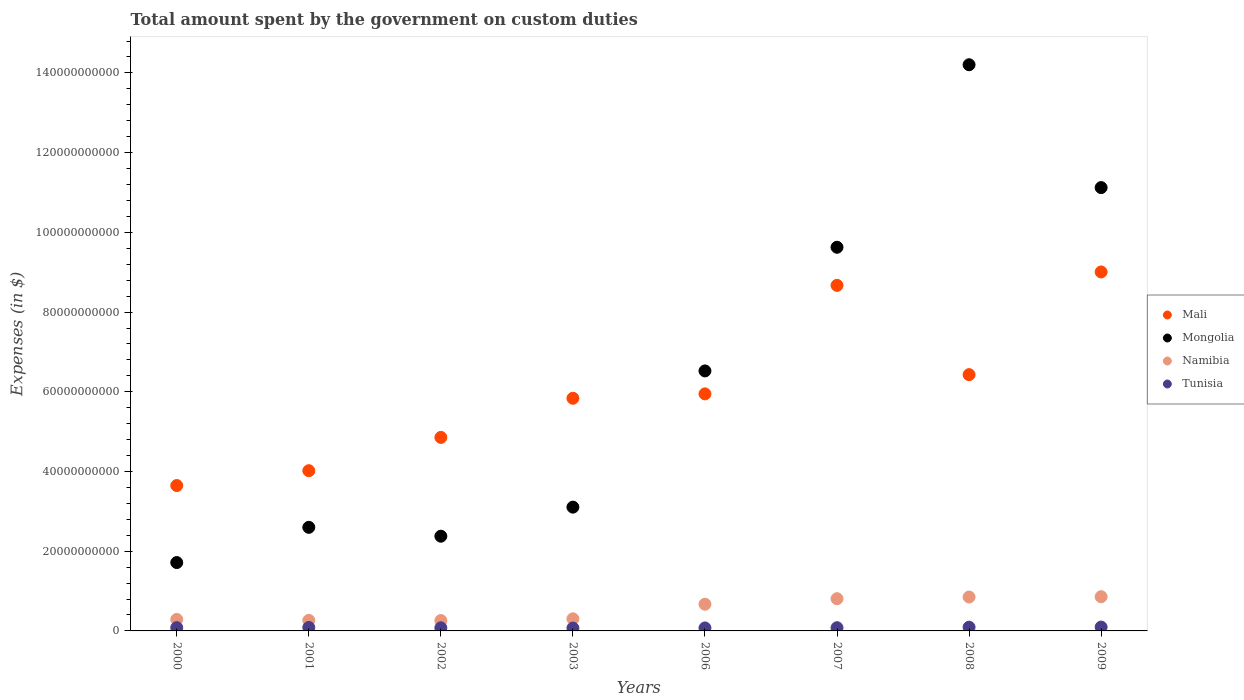What is the amount spent on custom duties by the government in Mali in 2002?
Your answer should be very brief. 4.86e+1. Across all years, what is the maximum amount spent on custom duties by the government in Namibia?
Provide a short and direct response. 8.59e+09. Across all years, what is the minimum amount spent on custom duties by the government in Tunisia?
Offer a terse response. 7.17e+08. In which year was the amount spent on custom duties by the government in Tunisia maximum?
Provide a short and direct response. 2009. What is the total amount spent on custom duties by the government in Tunisia in the graph?
Provide a short and direct response. 6.65e+09. What is the difference between the amount spent on custom duties by the government in Mongolia in 2008 and that in 2009?
Provide a succinct answer. 3.08e+1. What is the difference between the amount spent on custom duties by the government in Namibia in 2000 and the amount spent on custom duties by the government in Mali in 2009?
Your answer should be compact. -8.72e+1. What is the average amount spent on custom duties by the government in Namibia per year?
Offer a very short reply. 5.38e+09. In the year 2003, what is the difference between the amount spent on custom duties by the government in Namibia and amount spent on custom duties by the government in Mongolia?
Ensure brevity in your answer.  -2.80e+1. In how many years, is the amount spent on custom duties by the government in Tunisia greater than 24000000000 $?
Your answer should be compact. 0. What is the ratio of the amount spent on custom duties by the government in Namibia in 2008 to that in 2009?
Your response must be concise. 0.99. Is the amount spent on custom duties by the government in Tunisia in 2001 less than that in 2006?
Offer a very short reply. No. What is the difference between the highest and the second highest amount spent on custom duties by the government in Mali?
Provide a short and direct response. 3.36e+09. What is the difference between the highest and the lowest amount spent on custom duties by the government in Mongolia?
Offer a very short reply. 1.25e+11. Is the sum of the amount spent on custom duties by the government in Mongolia in 2002 and 2003 greater than the maximum amount spent on custom duties by the government in Namibia across all years?
Offer a very short reply. Yes. Is it the case that in every year, the sum of the amount spent on custom duties by the government in Mongolia and amount spent on custom duties by the government in Mali  is greater than the sum of amount spent on custom duties by the government in Tunisia and amount spent on custom duties by the government in Namibia?
Your answer should be very brief. No. Is it the case that in every year, the sum of the amount spent on custom duties by the government in Mali and amount spent on custom duties by the government in Namibia  is greater than the amount spent on custom duties by the government in Mongolia?
Give a very brief answer. No. Is the amount spent on custom duties by the government in Mongolia strictly greater than the amount spent on custom duties by the government in Tunisia over the years?
Make the answer very short. Yes. How many dotlines are there?
Make the answer very short. 4. How many years are there in the graph?
Provide a succinct answer. 8. Are the values on the major ticks of Y-axis written in scientific E-notation?
Offer a terse response. No. Does the graph contain any zero values?
Your response must be concise. No. Does the graph contain grids?
Make the answer very short. No. Where does the legend appear in the graph?
Provide a short and direct response. Center right. What is the title of the graph?
Offer a terse response. Total amount spent by the government on custom duties. Does "Austria" appear as one of the legend labels in the graph?
Your response must be concise. No. What is the label or title of the X-axis?
Give a very brief answer. Years. What is the label or title of the Y-axis?
Give a very brief answer. Expenses (in $). What is the Expenses (in $) in Mali in 2000?
Keep it short and to the point. 3.65e+1. What is the Expenses (in $) of Mongolia in 2000?
Give a very brief answer. 1.72e+1. What is the Expenses (in $) in Namibia in 2000?
Give a very brief answer. 2.88e+09. What is the Expenses (in $) of Tunisia in 2000?
Ensure brevity in your answer.  8.22e+08. What is the Expenses (in $) of Mali in 2001?
Offer a very short reply. 4.02e+1. What is the Expenses (in $) of Mongolia in 2001?
Your response must be concise. 2.60e+1. What is the Expenses (in $) of Namibia in 2001?
Your response must be concise. 2.64e+09. What is the Expenses (in $) in Tunisia in 2001?
Offer a terse response. 8.66e+08. What is the Expenses (in $) in Mali in 2002?
Your response must be concise. 4.86e+1. What is the Expenses (in $) of Mongolia in 2002?
Give a very brief answer. 2.38e+1. What is the Expenses (in $) of Namibia in 2002?
Ensure brevity in your answer.  2.60e+09. What is the Expenses (in $) of Tunisia in 2002?
Offer a very short reply. 7.81e+08. What is the Expenses (in $) of Mali in 2003?
Give a very brief answer. 5.84e+1. What is the Expenses (in $) in Mongolia in 2003?
Give a very brief answer. 3.11e+1. What is the Expenses (in $) of Namibia in 2003?
Keep it short and to the point. 3.04e+09. What is the Expenses (in $) of Tunisia in 2003?
Keep it short and to the point. 7.17e+08. What is the Expenses (in $) in Mali in 2006?
Provide a succinct answer. 5.95e+1. What is the Expenses (in $) of Mongolia in 2006?
Make the answer very short. 6.52e+1. What is the Expenses (in $) in Namibia in 2006?
Offer a terse response. 6.70e+09. What is the Expenses (in $) of Tunisia in 2006?
Make the answer very short. 7.47e+08. What is the Expenses (in $) of Mali in 2007?
Offer a terse response. 8.67e+1. What is the Expenses (in $) of Mongolia in 2007?
Keep it short and to the point. 9.63e+1. What is the Expenses (in $) in Namibia in 2007?
Ensure brevity in your answer.  8.09e+09. What is the Expenses (in $) of Tunisia in 2007?
Give a very brief answer. 8.04e+08. What is the Expenses (in $) in Mali in 2008?
Keep it short and to the point. 6.43e+1. What is the Expenses (in $) of Mongolia in 2008?
Provide a succinct answer. 1.42e+11. What is the Expenses (in $) in Namibia in 2008?
Your response must be concise. 8.50e+09. What is the Expenses (in $) in Tunisia in 2008?
Keep it short and to the point. 9.40e+08. What is the Expenses (in $) of Mali in 2009?
Provide a succinct answer. 9.01e+1. What is the Expenses (in $) of Mongolia in 2009?
Give a very brief answer. 1.11e+11. What is the Expenses (in $) of Namibia in 2009?
Offer a terse response. 8.59e+09. What is the Expenses (in $) of Tunisia in 2009?
Keep it short and to the point. 9.72e+08. Across all years, what is the maximum Expenses (in $) in Mali?
Provide a succinct answer. 9.01e+1. Across all years, what is the maximum Expenses (in $) in Mongolia?
Your response must be concise. 1.42e+11. Across all years, what is the maximum Expenses (in $) of Namibia?
Offer a terse response. 8.59e+09. Across all years, what is the maximum Expenses (in $) of Tunisia?
Make the answer very short. 9.72e+08. Across all years, what is the minimum Expenses (in $) of Mali?
Your response must be concise. 3.65e+1. Across all years, what is the minimum Expenses (in $) of Mongolia?
Provide a short and direct response. 1.72e+1. Across all years, what is the minimum Expenses (in $) in Namibia?
Your answer should be compact. 2.60e+09. Across all years, what is the minimum Expenses (in $) in Tunisia?
Make the answer very short. 7.17e+08. What is the total Expenses (in $) in Mali in the graph?
Provide a succinct answer. 4.84e+11. What is the total Expenses (in $) in Mongolia in the graph?
Your response must be concise. 5.13e+11. What is the total Expenses (in $) in Namibia in the graph?
Your answer should be very brief. 4.30e+1. What is the total Expenses (in $) of Tunisia in the graph?
Give a very brief answer. 6.65e+09. What is the difference between the Expenses (in $) in Mali in 2000 and that in 2001?
Give a very brief answer. -3.72e+09. What is the difference between the Expenses (in $) in Mongolia in 2000 and that in 2001?
Your response must be concise. -8.84e+09. What is the difference between the Expenses (in $) in Namibia in 2000 and that in 2001?
Ensure brevity in your answer.  2.35e+08. What is the difference between the Expenses (in $) in Tunisia in 2000 and that in 2001?
Provide a succinct answer. -4.38e+07. What is the difference between the Expenses (in $) of Mali in 2000 and that in 2002?
Provide a succinct answer. -1.21e+1. What is the difference between the Expenses (in $) of Mongolia in 2000 and that in 2002?
Offer a very short reply. -6.61e+09. What is the difference between the Expenses (in $) in Namibia in 2000 and that in 2002?
Your answer should be very brief. 2.79e+08. What is the difference between the Expenses (in $) of Tunisia in 2000 and that in 2002?
Provide a succinct answer. 4.11e+07. What is the difference between the Expenses (in $) in Mali in 2000 and that in 2003?
Provide a short and direct response. -2.19e+1. What is the difference between the Expenses (in $) of Mongolia in 2000 and that in 2003?
Provide a short and direct response. -1.39e+1. What is the difference between the Expenses (in $) of Namibia in 2000 and that in 2003?
Offer a very short reply. -1.59e+08. What is the difference between the Expenses (in $) in Tunisia in 2000 and that in 2003?
Keep it short and to the point. 1.05e+08. What is the difference between the Expenses (in $) in Mali in 2000 and that in 2006?
Provide a succinct answer. -2.30e+1. What is the difference between the Expenses (in $) in Mongolia in 2000 and that in 2006?
Give a very brief answer. -4.81e+1. What is the difference between the Expenses (in $) of Namibia in 2000 and that in 2006?
Your answer should be very brief. -3.82e+09. What is the difference between the Expenses (in $) in Tunisia in 2000 and that in 2006?
Provide a short and direct response. 7.54e+07. What is the difference between the Expenses (in $) in Mali in 2000 and that in 2007?
Make the answer very short. -5.02e+1. What is the difference between the Expenses (in $) of Mongolia in 2000 and that in 2007?
Offer a very short reply. -7.91e+1. What is the difference between the Expenses (in $) of Namibia in 2000 and that in 2007?
Offer a terse response. -5.21e+09. What is the difference between the Expenses (in $) of Tunisia in 2000 and that in 2007?
Provide a succinct answer. 1.88e+07. What is the difference between the Expenses (in $) in Mali in 2000 and that in 2008?
Ensure brevity in your answer.  -2.78e+1. What is the difference between the Expenses (in $) in Mongolia in 2000 and that in 2008?
Make the answer very short. -1.25e+11. What is the difference between the Expenses (in $) of Namibia in 2000 and that in 2008?
Your answer should be very brief. -5.62e+09. What is the difference between the Expenses (in $) in Tunisia in 2000 and that in 2008?
Your answer should be very brief. -1.18e+08. What is the difference between the Expenses (in $) in Mali in 2000 and that in 2009?
Your response must be concise. -5.36e+1. What is the difference between the Expenses (in $) in Mongolia in 2000 and that in 2009?
Your answer should be very brief. -9.41e+1. What is the difference between the Expenses (in $) in Namibia in 2000 and that in 2009?
Your answer should be compact. -5.71e+09. What is the difference between the Expenses (in $) of Tunisia in 2000 and that in 2009?
Provide a succinct answer. -1.50e+08. What is the difference between the Expenses (in $) of Mali in 2001 and that in 2002?
Ensure brevity in your answer.  -8.35e+09. What is the difference between the Expenses (in $) in Mongolia in 2001 and that in 2002?
Make the answer very short. 2.22e+09. What is the difference between the Expenses (in $) in Namibia in 2001 and that in 2002?
Your answer should be very brief. 4.42e+07. What is the difference between the Expenses (in $) of Tunisia in 2001 and that in 2002?
Provide a succinct answer. 8.49e+07. What is the difference between the Expenses (in $) of Mali in 2001 and that in 2003?
Ensure brevity in your answer.  -1.82e+1. What is the difference between the Expenses (in $) of Mongolia in 2001 and that in 2003?
Offer a very short reply. -5.07e+09. What is the difference between the Expenses (in $) in Namibia in 2001 and that in 2003?
Make the answer very short. -3.94e+08. What is the difference between the Expenses (in $) of Tunisia in 2001 and that in 2003?
Keep it short and to the point. 1.49e+08. What is the difference between the Expenses (in $) in Mali in 2001 and that in 2006?
Keep it short and to the point. -1.93e+1. What is the difference between the Expenses (in $) in Mongolia in 2001 and that in 2006?
Provide a short and direct response. -3.92e+1. What is the difference between the Expenses (in $) in Namibia in 2001 and that in 2006?
Make the answer very short. -4.06e+09. What is the difference between the Expenses (in $) in Tunisia in 2001 and that in 2006?
Offer a very short reply. 1.19e+08. What is the difference between the Expenses (in $) of Mali in 2001 and that in 2007?
Your response must be concise. -4.65e+1. What is the difference between the Expenses (in $) in Mongolia in 2001 and that in 2007?
Give a very brief answer. -7.03e+1. What is the difference between the Expenses (in $) in Namibia in 2001 and that in 2007?
Your answer should be compact. -5.44e+09. What is the difference between the Expenses (in $) of Tunisia in 2001 and that in 2007?
Make the answer very short. 6.26e+07. What is the difference between the Expenses (in $) in Mali in 2001 and that in 2008?
Your answer should be compact. -2.41e+1. What is the difference between the Expenses (in $) of Mongolia in 2001 and that in 2008?
Offer a terse response. -1.16e+11. What is the difference between the Expenses (in $) in Namibia in 2001 and that in 2008?
Give a very brief answer. -5.86e+09. What is the difference between the Expenses (in $) in Tunisia in 2001 and that in 2008?
Provide a short and direct response. -7.37e+07. What is the difference between the Expenses (in $) in Mali in 2001 and that in 2009?
Keep it short and to the point. -4.99e+1. What is the difference between the Expenses (in $) in Mongolia in 2001 and that in 2009?
Offer a terse response. -8.52e+1. What is the difference between the Expenses (in $) in Namibia in 2001 and that in 2009?
Offer a very short reply. -5.94e+09. What is the difference between the Expenses (in $) in Tunisia in 2001 and that in 2009?
Give a very brief answer. -1.06e+08. What is the difference between the Expenses (in $) of Mali in 2002 and that in 2003?
Ensure brevity in your answer.  -9.82e+09. What is the difference between the Expenses (in $) in Mongolia in 2002 and that in 2003?
Make the answer very short. -7.29e+09. What is the difference between the Expenses (in $) in Namibia in 2002 and that in 2003?
Offer a very short reply. -4.38e+08. What is the difference between the Expenses (in $) of Tunisia in 2002 and that in 2003?
Give a very brief answer. 6.41e+07. What is the difference between the Expenses (in $) in Mali in 2002 and that in 2006?
Give a very brief answer. -1.09e+1. What is the difference between the Expenses (in $) in Mongolia in 2002 and that in 2006?
Your answer should be very brief. -4.15e+1. What is the difference between the Expenses (in $) of Namibia in 2002 and that in 2006?
Give a very brief answer. -4.10e+09. What is the difference between the Expenses (in $) of Tunisia in 2002 and that in 2006?
Make the answer very short. 3.43e+07. What is the difference between the Expenses (in $) in Mali in 2002 and that in 2007?
Your answer should be compact. -3.81e+1. What is the difference between the Expenses (in $) of Mongolia in 2002 and that in 2007?
Provide a short and direct response. -7.25e+1. What is the difference between the Expenses (in $) in Namibia in 2002 and that in 2007?
Provide a short and direct response. -5.49e+09. What is the difference between the Expenses (in $) of Tunisia in 2002 and that in 2007?
Ensure brevity in your answer.  -2.23e+07. What is the difference between the Expenses (in $) in Mali in 2002 and that in 2008?
Your answer should be very brief. -1.57e+1. What is the difference between the Expenses (in $) in Mongolia in 2002 and that in 2008?
Provide a succinct answer. -1.18e+11. What is the difference between the Expenses (in $) in Namibia in 2002 and that in 2008?
Make the answer very short. -5.90e+09. What is the difference between the Expenses (in $) of Tunisia in 2002 and that in 2008?
Make the answer very short. -1.59e+08. What is the difference between the Expenses (in $) in Mali in 2002 and that in 2009?
Give a very brief answer. -4.15e+1. What is the difference between the Expenses (in $) in Mongolia in 2002 and that in 2009?
Your answer should be compact. -8.75e+1. What is the difference between the Expenses (in $) of Namibia in 2002 and that in 2009?
Ensure brevity in your answer.  -5.99e+09. What is the difference between the Expenses (in $) of Tunisia in 2002 and that in 2009?
Provide a short and direct response. -1.91e+08. What is the difference between the Expenses (in $) of Mali in 2003 and that in 2006?
Offer a very short reply. -1.10e+09. What is the difference between the Expenses (in $) of Mongolia in 2003 and that in 2006?
Provide a succinct answer. -3.42e+1. What is the difference between the Expenses (in $) in Namibia in 2003 and that in 2006?
Provide a short and direct response. -3.66e+09. What is the difference between the Expenses (in $) of Tunisia in 2003 and that in 2006?
Provide a succinct answer. -2.98e+07. What is the difference between the Expenses (in $) in Mali in 2003 and that in 2007?
Keep it short and to the point. -2.83e+1. What is the difference between the Expenses (in $) of Mongolia in 2003 and that in 2007?
Ensure brevity in your answer.  -6.52e+1. What is the difference between the Expenses (in $) in Namibia in 2003 and that in 2007?
Provide a succinct answer. -5.05e+09. What is the difference between the Expenses (in $) of Tunisia in 2003 and that in 2007?
Keep it short and to the point. -8.64e+07. What is the difference between the Expenses (in $) in Mali in 2003 and that in 2008?
Provide a succinct answer. -5.92e+09. What is the difference between the Expenses (in $) of Mongolia in 2003 and that in 2008?
Your response must be concise. -1.11e+11. What is the difference between the Expenses (in $) of Namibia in 2003 and that in 2008?
Give a very brief answer. -5.47e+09. What is the difference between the Expenses (in $) of Tunisia in 2003 and that in 2008?
Ensure brevity in your answer.  -2.23e+08. What is the difference between the Expenses (in $) of Mali in 2003 and that in 2009?
Ensure brevity in your answer.  -3.17e+1. What is the difference between the Expenses (in $) of Mongolia in 2003 and that in 2009?
Provide a succinct answer. -8.02e+1. What is the difference between the Expenses (in $) in Namibia in 2003 and that in 2009?
Ensure brevity in your answer.  -5.55e+09. What is the difference between the Expenses (in $) of Tunisia in 2003 and that in 2009?
Provide a short and direct response. -2.55e+08. What is the difference between the Expenses (in $) in Mali in 2006 and that in 2007?
Provide a succinct answer. -2.72e+1. What is the difference between the Expenses (in $) of Mongolia in 2006 and that in 2007?
Your response must be concise. -3.10e+1. What is the difference between the Expenses (in $) in Namibia in 2006 and that in 2007?
Your answer should be very brief. -1.39e+09. What is the difference between the Expenses (in $) in Tunisia in 2006 and that in 2007?
Provide a short and direct response. -5.66e+07. What is the difference between the Expenses (in $) in Mali in 2006 and that in 2008?
Your answer should be very brief. -4.83e+09. What is the difference between the Expenses (in $) of Mongolia in 2006 and that in 2008?
Offer a terse response. -7.68e+1. What is the difference between the Expenses (in $) in Namibia in 2006 and that in 2008?
Your response must be concise. -1.80e+09. What is the difference between the Expenses (in $) in Tunisia in 2006 and that in 2008?
Keep it short and to the point. -1.93e+08. What is the difference between the Expenses (in $) in Mali in 2006 and that in 2009?
Ensure brevity in your answer.  -3.06e+1. What is the difference between the Expenses (in $) of Mongolia in 2006 and that in 2009?
Provide a succinct answer. -4.60e+1. What is the difference between the Expenses (in $) in Namibia in 2006 and that in 2009?
Your response must be concise. -1.89e+09. What is the difference between the Expenses (in $) in Tunisia in 2006 and that in 2009?
Offer a very short reply. -2.25e+08. What is the difference between the Expenses (in $) of Mali in 2007 and that in 2008?
Your answer should be very brief. 2.24e+1. What is the difference between the Expenses (in $) in Mongolia in 2007 and that in 2008?
Your answer should be very brief. -4.58e+1. What is the difference between the Expenses (in $) of Namibia in 2007 and that in 2008?
Provide a short and direct response. -4.17e+08. What is the difference between the Expenses (in $) in Tunisia in 2007 and that in 2008?
Your answer should be compact. -1.36e+08. What is the difference between the Expenses (in $) of Mali in 2007 and that in 2009?
Provide a succinct answer. -3.36e+09. What is the difference between the Expenses (in $) in Mongolia in 2007 and that in 2009?
Offer a terse response. -1.50e+1. What is the difference between the Expenses (in $) of Namibia in 2007 and that in 2009?
Your response must be concise. -5.00e+08. What is the difference between the Expenses (in $) of Tunisia in 2007 and that in 2009?
Make the answer very short. -1.68e+08. What is the difference between the Expenses (in $) in Mali in 2008 and that in 2009?
Ensure brevity in your answer.  -2.58e+1. What is the difference between the Expenses (in $) in Mongolia in 2008 and that in 2009?
Provide a short and direct response. 3.08e+1. What is the difference between the Expenses (in $) of Namibia in 2008 and that in 2009?
Your response must be concise. -8.30e+07. What is the difference between the Expenses (in $) in Tunisia in 2008 and that in 2009?
Your response must be concise. -3.20e+07. What is the difference between the Expenses (in $) in Mali in 2000 and the Expenses (in $) in Mongolia in 2001?
Your answer should be compact. 1.05e+1. What is the difference between the Expenses (in $) in Mali in 2000 and the Expenses (in $) in Namibia in 2001?
Offer a terse response. 3.38e+1. What is the difference between the Expenses (in $) in Mali in 2000 and the Expenses (in $) in Tunisia in 2001?
Your answer should be compact. 3.56e+1. What is the difference between the Expenses (in $) in Mongolia in 2000 and the Expenses (in $) in Namibia in 2001?
Keep it short and to the point. 1.45e+1. What is the difference between the Expenses (in $) of Mongolia in 2000 and the Expenses (in $) of Tunisia in 2001?
Keep it short and to the point. 1.63e+1. What is the difference between the Expenses (in $) in Namibia in 2000 and the Expenses (in $) in Tunisia in 2001?
Offer a very short reply. 2.01e+09. What is the difference between the Expenses (in $) of Mali in 2000 and the Expenses (in $) of Mongolia in 2002?
Offer a terse response. 1.27e+1. What is the difference between the Expenses (in $) in Mali in 2000 and the Expenses (in $) in Namibia in 2002?
Offer a very short reply. 3.39e+1. What is the difference between the Expenses (in $) in Mali in 2000 and the Expenses (in $) in Tunisia in 2002?
Provide a short and direct response. 3.57e+1. What is the difference between the Expenses (in $) of Mongolia in 2000 and the Expenses (in $) of Namibia in 2002?
Provide a succinct answer. 1.46e+1. What is the difference between the Expenses (in $) of Mongolia in 2000 and the Expenses (in $) of Tunisia in 2002?
Offer a very short reply. 1.64e+1. What is the difference between the Expenses (in $) of Namibia in 2000 and the Expenses (in $) of Tunisia in 2002?
Keep it short and to the point. 2.10e+09. What is the difference between the Expenses (in $) of Mali in 2000 and the Expenses (in $) of Mongolia in 2003?
Ensure brevity in your answer.  5.42e+09. What is the difference between the Expenses (in $) in Mali in 2000 and the Expenses (in $) in Namibia in 2003?
Provide a succinct answer. 3.34e+1. What is the difference between the Expenses (in $) of Mali in 2000 and the Expenses (in $) of Tunisia in 2003?
Provide a short and direct response. 3.58e+1. What is the difference between the Expenses (in $) of Mongolia in 2000 and the Expenses (in $) of Namibia in 2003?
Your answer should be very brief. 1.41e+1. What is the difference between the Expenses (in $) in Mongolia in 2000 and the Expenses (in $) in Tunisia in 2003?
Ensure brevity in your answer.  1.64e+1. What is the difference between the Expenses (in $) of Namibia in 2000 and the Expenses (in $) of Tunisia in 2003?
Your answer should be very brief. 2.16e+09. What is the difference between the Expenses (in $) in Mali in 2000 and the Expenses (in $) in Mongolia in 2006?
Your answer should be very brief. -2.88e+1. What is the difference between the Expenses (in $) of Mali in 2000 and the Expenses (in $) of Namibia in 2006?
Ensure brevity in your answer.  2.98e+1. What is the difference between the Expenses (in $) of Mali in 2000 and the Expenses (in $) of Tunisia in 2006?
Your answer should be compact. 3.57e+1. What is the difference between the Expenses (in $) of Mongolia in 2000 and the Expenses (in $) of Namibia in 2006?
Keep it short and to the point. 1.05e+1. What is the difference between the Expenses (in $) in Mongolia in 2000 and the Expenses (in $) in Tunisia in 2006?
Your response must be concise. 1.64e+1. What is the difference between the Expenses (in $) of Namibia in 2000 and the Expenses (in $) of Tunisia in 2006?
Make the answer very short. 2.13e+09. What is the difference between the Expenses (in $) of Mali in 2000 and the Expenses (in $) of Mongolia in 2007?
Your response must be concise. -5.98e+1. What is the difference between the Expenses (in $) in Mali in 2000 and the Expenses (in $) in Namibia in 2007?
Your response must be concise. 2.84e+1. What is the difference between the Expenses (in $) of Mali in 2000 and the Expenses (in $) of Tunisia in 2007?
Your answer should be very brief. 3.57e+1. What is the difference between the Expenses (in $) of Mongolia in 2000 and the Expenses (in $) of Namibia in 2007?
Provide a short and direct response. 9.07e+09. What is the difference between the Expenses (in $) of Mongolia in 2000 and the Expenses (in $) of Tunisia in 2007?
Ensure brevity in your answer.  1.63e+1. What is the difference between the Expenses (in $) of Namibia in 2000 and the Expenses (in $) of Tunisia in 2007?
Make the answer very short. 2.07e+09. What is the difference between the Expenses (in $) in Mali in 2000 and the Expenses (in $) in Mongolia in 2008?
Give a very brief answer. -1.06e+11. What is the difference between the Expenses (in $) of Mali in 2000 and the Expenses (in $) of Namibia in 2008?
Ensure brevity in your answer.  2.80e+1. What is the difference between the Expenses (in $) of Mali in 2000 and the Expenses (in $) of Tunisia in 2008?
Offer a terse response. 3.55e+1. What is the difference between the Expenses (in $) in Mongolia in 2000 and the Expenses (in $) in Namibia in 2008?
Ensure brevity in your answer.  8.65e+09. What is the difference between the Expenses (in $) of Mongolia in 2000 and the Expenses (in $) of Tunisia in 2008?
Provide a succinct answer. 1.62e+1. What is the difference between the Expenses (in $) of Namibia in 2000 and the Expenses (in $) of Tunisia in 2008?
Your response must be concise. 1.94e+09. What is the difference between the Expenses (in $) of Mali in 2000 and the Expenses (in $) of Mongolia in 2009?
Provide a short and direct response. -7.48e+1. What is the difference between the Expenses (in $) of Mali in 2000 and the Expenses (in $) of Namibia in 2009?
Offer a terse response. 2.79e+1. What is the difference between the Expenses (in $) of Mali in 2000 and the Expenses (in $) of Tunisia in 2009?
Give a very brief answer. 3.55e+1. What is the difference between the Expenses (in $) of Mongolia in 2000 and the Expenses (in $) of Namibia in 2009?
Make the answer very short. 8.57e+09. What is the difference between the Expenses (in $) of Mongolia in 2000 and the Expenses (in $) of Tunisia in 2009?
Provide a succinct answer. 1.62e+1. What is the difference between the Expenses (in $) of Namibia in 2000 and the Expenses (in $) of Tunisia in 2009?
Your answer should be compact. 1.91e+09. What is the difference between the Expenses (in $) in Mali in 2001 and the Expenses (in $) in Mongolia in 2002?
Your answer should be compact. 1.64e+1. What is the difference between the Expenses (in $) in Mali in 2001 and the Expenses (in $) in Namibia in 2002?
Provide a short and direct response. 3.76e+1. What is the difference between the Expenses (in $) of Mali in 2001 and the Expenses (in $) of Tunisia in 2002?
Your answer should be very brief. 3.94e+1. What is the difference between the Expenses (in $) of Mongolia in 2001 and the Expenses (in $) of Namibia in 2002?
Give a very brief answer. 2.34e+1. What is the difference between the Expenses (in $) in Mongolia in 2001 and the Expenses (in $) in Tunisia in 2002?
Offer a terse response. 2.52e+1. What is the difference between the Expenses (in $) in Namibia in 2001 and the Expenses (in $) in Tunisia in 2002?
Keep it short and to the point. 1.86e+09. What is the difference between the Expenses (in $) in Mali in 2001 and the Expenses (in $) in Mongolia in 2003?
Make the answer very short. 9.14e+09. What is the difference between the Expenses (in $) in Mali in 2001 and the Expenses (in $) in Namibia in 2003?
Make the answer very short. 3.72e+1. What is the difference between the Expenses (in $) in Mali in 2001 and the Expenses (in $) in Tunisia in 2003?
Make the answer very short. 3.95e+1. What is the difference between the Expenses (in $) of Mongolia in 2001 and the Expenses (in $) of Namibia in 2003?
Offer a terse response. 2.30e+1. What is the difference between the Expenses (in $) in Mongolia in 2001 and the Expenses (in $) in Tunisia in 2003?
Give a very brief answer. 2.53e+1. What is the difference between the Expenses (in $) of Namibia in 2001 and the Expenses (in $) of Tunisia in 2003?
Your response must be concise. 1.93e+09. What is the difference between the Expenses (in $) in Mali in 2001 and the Expenses (in $) in Mongolia in 2006?
Provide a short and direct response. -2.50e+1. What is the difference between the Expenses (in $) of Mali in 2001 and the Expenses (in $) of Namibia in 2006?
Provide a short and direct response. 3.35e+1. What is the difference between the Expenses (in $) in Mali in 2001 and the Expenses (in $) in Tunisia in 2006?
Give a very brief answer. 3.95e+1. What is the difference between the Expenses (in $) in Mongolia in 2001 and the Expenses (in $) in Namibia in 2006?
Provide a succinct answer. 1.93e+1. What is the difference between the Expenses (in $) of Mongolia in 2001 and the Expenses (in $) of Tunisia in 2006?
Ensure brevity in your answer.  2.52e+1. What is the difference between the Expenses (in $) in Namibia in 2001 and the Expenses (in $) in Tunisia in 2006?
Provide a succinct answer. 1.90e+09. What is the difference between the Expenses (in $) of Mali in 2001 and the Expenses (in $) of Mongolia in 2007?
Make the answer very short. -5.61e+1. What is the difference between the Expenses (in $) in Mali in 2001 and the Expenses (in $) in Namibia in 2007?
Provide a short and direct response. 3.21e+1. What is the difference between the Expenses (in $) in Mali in 2001 and the Expenses (in $) in Tunisia in 2007?
Ensure brevity in your answer.  3.94e+1. What is the difference between the Expenses (in $) in Mongolia in 2001 and the Expenses (in $) in Namibia in 2007?
Offer a very short reply. 1.79e+1. What is the difference between the Expenses (in $) in Mongolia in 2001 and the Expenses (in $) in Tunisia in 2007?
Provide a short and direct response. 2.52e+1. What is the difference between the Expenses (in $) of Namibia in 2001 and the Expenses (in $) of Tunisia in 2007?
Make the answer very short. 1.84e+09. What is the difference between the Expenses (in $) of Mali in 2001 and the Expenses (in $) of Mongolia in 2008?
Make the answer very short. -1.02e+11. What is the difference between the Expenses (in $) in Mali in 2001 and the Expenses (in $) in Namibia in 2008?
Make the answer very short. 3.17e+1. What is the difference between the Expenses (in $) in Mali in 2001 and the Expenses (in $) in Tunisia in 2008?
Make the answer very short. 3.93e+1. What is the difference between the Expenses (in $) of Mongolia in 2001 and the Expenses (in $) of Namibia in 2008?
Your answer should be compact. 1.75e+1. What is the difference between the Expenses (in $) of Mongolia in 2001 and the Expenses (in $) of Tunisia in 2008?
Offer a terse response. 2.51e+1. What is the difference between the Expenses (in $) of Namibia in 2001 and the Expenses (in $) of Tunisia in 2008?
Give a very brief answer. 1.70e+09. What is the difference between the Expenses (in $) of Mali in 2001 and the Expenses (in $) of Mongolia in 2009?
Offer a terse response. -7.10e+1. What is the difference between the Expenses (in $) of Mali in 2001 and the Expenses (in $) of Namibia in 2009?
Provide a short and direct response. 3.16e+1. What is the difference between the Expenses (in $) in Mali in 2001 and the Expenses (in $) in Tunisia in 2009?
Ensure brevity in your answer.  3.92e+1. What is the difference between the Expenses (in $) in Mongolia in 2001 and the Expenses (in $) in Namibia in 2009?
Ensure brevity in your answer.  1.74e+1. What is the difference between the Expenses (in $) of Mongolia in 2001 and the Expenses (in $) of Tunisia in 2009?
Give a very brief answer. 2.50e+1. What is the difference between the Expenses (in $) in Namibia in 2001 and the Expenses (in $) in Tunisia in 2009?
Provide a succinct answer. 1.67e+09. What is the difference between the Expenses (in $) of Mali in 2002 and the Expenses (in $) of Mongolia in 2003?
Ensure brevity in your answer.  1.75e+1. What is the difference between the Expenses (in $) of Mali in 2002 and the Expenses (in $) of Namibia in 2003?
Provide a succinct answer. 4.55e+1. What is the difference between the Expenses (in $) in Mali in 2002 and the Expenses (in $) in Tunisia in 2003?
Provide a short and direct response. 4.78e+1. What is the difference between the Expenses (in $) of Mongolia in 2002 and the Expenses (in $) of Namibia in 2003?
Your answer should be very brief. 2.07e+1. What is the difference between the Expenses (in $) in Mongolia in 2002 and the Expenses (in $) in Tunisia in 2003?
Ensure brevity in your answer.  2.31e+1. What is the difference between the Expenses (in $) in Namibia in 2002 and the Expenses (in $) in Tunisia in 2003?
Provide a short and direct response. 1.88e+09. What is the difference between the Expenses (in $) of Mali in 2002 and the Expenses (in $) of Mongolia in 2006?
Your response must be concise. -1.67e+1. What is the difference between the Expenses (in $) of Mali in 2002 and the Expenses (in $) of Namibia in 2006?
Make the answer very short. 4.19e+1. What is the difference between the Expenses (in $) of Mali in 2002 and the Expenses (in $) of Tunisia in 2006?
Your answer should be compact. 4.78e+1. What is the difference between the Expenses (in $) of Mongolia in 2002 and the Expenses (in $) of Namibia in 2006?
Your response must be concise. 1.71e+1. What is the difference between the Expenses (in $) in Mongolia in 2002 and the Expenses (in $) in Tunisia in 2006?
Offer a very short reply. 2.30e+1. What is the difference between the Expenses (in $) in Namibia in 2002 and the Expenses (in $) in Tunisia in 2006?
Offer a terse response. 1.85e+09. What is the difference between the Expenses (in $) in Mali in 2002 and the Expenses (in $) in Mongolia in 2007?
Offer a terse response. -4.77e+1. What is the difference between the Expenses (in $) of Mali in 2002 and the Expenses (in $) of Namibia in 2007?
Provide a short and direct response. 4.05e+1. What is the difference between the Expenses (in $) in Mali in 2002 and the Expenses (in $) in Tunisia in 2007?
Provide a succinct answer. 4.77e+1. What is the difference between the Expenses (in $) in Mongolia in 2002 and the Expenses (in $) in Namibia in 2007?
Your answer should be compact. 1.57e+1. What is the difference between the Expenses (in $) in Mongolia in 2002 and the Expenses (in $) in Tunisia in 2007?
Offer a terse response. 2.30e+1. What is the difference between the Expenses (in $) of Namibia in 2002 and the Expenses (in $) of Tunisia in 2007?
Keep it short and to the point. 1.79e+09. What is the difference between the Expenses (in $) in Mali in 2002 and the Expenses (in $) in Mongolia in 2008?
Your answer should be very brief. -9.35e+1. What is the difference between the Expenses (in $) in Mali in 2002 and the Expenses (in $) in Namibia in 2008?
Provide a short and direct response. 4.01e+1. What is the difference between the Expenses (in $) in Mali in 2002 and the Expenses (in $) in Tunisia in 2008?
Give a very brief answer. 4.76e+1. What is the difference between the Expenses (in $) of Mongolia in 2002 and the Expenses (in $) of Namibia in 2008?
Your answer should be very brief. 1.53e+1. What is the difference between the Expenses (in $) of Mongolia in 2002 and the Expenses (in $) of Tunisia in 2008?
Provide a short and direct response. 2.28e+1. What is the difference between the Expenses (in $) in Namibia in 2002 and the Expenses (in $) in Tunisia in 2008?
Your answer should be compact. 1.66e+09. What is the difference between the Expenses (in $) in Mali in 2002 and the Expenses (in $) in Mongolia in 2009?
Provide a short and direct response. -6.27e+1. What is the difference between the Expenses (in $) of Mali in 2002 and the Expenses (in $) of Namibia in 2009?
Provide a short and direct response. 4.00e+1. What is the difference between the Expenses (in $) of Mali in 2002 and the Expenses (in $) of Tunisia in 2009?
Your answer should be very brief. 4.76e+1. What is the difference between the Expenses (in $) in Mongolia in 2002 and the Expenses (in $) in Namibia in 2009?
Your response must be concise. 1.52e+1. What is the difference between the Expenses (in $) of Mongolia in 2002 and the Expenses (in $) of Tunisia in 2009?
Your answer should be very brief. 2.28e+1. What is the difference between the Expenses (in $) in Namibia in 2002 and the Expenses (in $) in Tunisia in 2009?
Make the answer very short. 1.63e+09. What is the difference between the Expenses (in $) in Mali in 2003 and the Expenses (in $) in Mongolia in 2006?
Offer a terse response. -6.86e+09. What is the difference between the Expenses (in $) of Mali in 2003 and the Expenses (in $) of Namibia in 2006?
Your answer should be compact. 5.17e+1. What is the difference between the Expenses (in $) in Mali in 2003 and the Expenses (in $) in Tunisia in 2006?
Keep it short and to the point. 5.76e+1. What is the difference between the Expenses (in $) in Mongolia in 2003 and the Expenses (in $) in Namibia in 2006?
Make the answer very short. 2.44e+1. What is the difference between the Expenses (in $) of Mongolia in 2003 and the Expenses (in $) of Tunisia in 2006?
Give a very brief answer. 3.03e+1. What is the difference between the Expenses (in $) of Namibia in 2003 and the Expenses (in $) of Tunisia in 2006?
Your answer should be compact. 2.29e+09. What is the difference between the Expenses (in $) in Mali in 2003 and the Expenses (in $) in Mongolia in 2007?
Your response must be concise. -3.79e+1. What is the difference between the Expenses (in $) of Mali in 2003 and the Expenses (in $) of Namibia in 2007?
Provide a succinct answer. 5.03e+1. What is the difference between the Expenses (in $) of Mali in 2003 and the Expenses (in $) of Tunisia in 2007?
Offer a terse response. 5.76e+1. What is the difference between the Expenses (in $) in Mongolia in 2003 and the Expenses (in $) in Namibia in 2007?
Provide a short and direct response. 2.30e+1. What is the difference between the Expenses (in $) of Mongolia in 2003 and the Expenses (in $) of Tunisia in 2007?
Your answer should be very brief. 3.03e+1. What is the difference between the Expenses (in $) of Namibia in 2003 and the Expenses (in $) of Tunisia in 2007?
Your answer should be compact. 2.23e+09. What is the difference between the Expenses (in $) of Mali in 2003 and the Expenses (in $) of Mongolia in 2008?
Offer a very short reply. -8.37e+1. What is the difference between the Expenses (in $) in Mali in 2003 and the Expenses (in $) in Namibia in 2008?
Give a very brief answer. 4.99e+1. What is the difference between the Expenses (in $) in Mali in 2003 and the Expenses (in $) in Tunisia in 2008?
Offer a very short reply. 5.74e+1. What is the difference between the Expenses (in $) of Mongolia in 2003 and the Expenses (in $) of Namibia in 2008?
Give a very brief answer. 2.26e+1. What is the difference between the Expenses (in $) of Mongolia in 2003 and the Expenses (in $) of Tunisia in 2008?
Keep it short and to the point. 3.01e+1. What is the difference between the Expenses (in $) of Namibia in 2003 and the Expenses (in $) of Tunisia in 2008?
Give a very brief answer. 2.10e+09. What is the difference between the Expenses (in $) in Mali in 2003 and the Expenses (in $) in Mongolia in 2009?
Make the answer very short. -5.29e+1. What is the difference between the Expenses (in $) of Mali in 2003 and the Expenses (in $) of Namibia in 2009?
Provide a short and direct response. 4.98e+1. What is the difference between the Expenses (in $) of Mali in 2003 and the Expenses (in $) of Tunisia in 2009?
Your answer should be compact. 5.74e+1. What is the difference between the Expenses (in $) in Mongolia in 2003 and the Expenses (in $) in Namibia in 2009?
Keep it short and to the point. 2.25e+1. What is the difference between the Expenses (in $) in Mongolia in 2003 and the Expenses (in $) in Tunisia in 2009?
Provide a short and direct response. 3.01e+1. What is the difference between the Expenses (in $) of Namibia in 2003 and the Expenses (in $) of Tunisia in 2009?
Ensure brevity in your answer.  2.06e+09. What is the difference between the Expenses (in $) of Mali in 2006 and the Expenses (in $) of Mongolia in 2007?
Offer a very short reply. -3.68e+1. What is the difference between the Expenses (in $) in Mali in 2006 and the Expenses (in $) in Namibia in 2007?
Offer a very short reply. 5.14e+1. What is the difference between the Expenses (in $) in Mali in 2006 and the Expenses (in $) in Tunisia in 2007?
Provide a succinct answer. 5.87e+1. What is the difference between the Expenses (in $) in Mongolia in 2006 and the Expenses (in $) in Namibia in 2007?
Offer a terse response. 5.71e+1. What is the difference between the Expenses (in $) of Mongolia in 2006 and the Expenses (in $) of Tunisia in 2007?
Provide a succinct answer. 6.44e+1. What is the difference between the Expenses (in $) of Namibia in 2006 and the Expenses (in $) of Tunisia in 2007?
Your answer should be compact. 5.89e+09. What is the difference between the Expenses (in $) in Mali in 2006 and the Expenses (in $) in Mongolia in 2008?
Offer a very short reply. -8.26e+1. What is the difference between the Expenses (in $) in Mali in 2006 and the Expenses (in $) in Namibia in 2008?
Your response must be concise. 5.10e+1. What is the difference between the Expenses (in $) of Mali in 2006 and the Expenses (in $) of Tunisia in 2008?
Your answer should be very brief. 5.85e+1. What is the difference between the Expenses (in $) of Mongolia in 2006 and the Expenses (in $) of Namibia in 2008?
Offer a very short reply. 5.67e+1. What is the difference between the Expenses (in $) in Mongolia in 2006 and the Expenses (in $) in Tunisia in 2008?
Keep it short and to the point. 6.43e+1. What is the difference between the Expenses (in $) of Namibia in 2006 and the Expenses (in $) of Tunisia in 2008?
Provide a succinct answer. 5.76e+09. What is the difference between the Expenses (in $) in Mali in 2006 and the Expenses (in $) in Mongolia in 2009?
Offer a terse response. -5.18e+1. What is the difference between the Expenses (in $) in Mali in 2006 and the Expenses (in $) in Namibia in 2009?
Ensure brevity in your answer.  5.09e+1. What is the difference between the Expenses (in $) in Mali in 2006 and the Expenses (in $) in Tunisia in 2009?
Offer a very short reply. 5.85e+1. What is the difference between the Expenses (in $) in Mongolia in 2006 and the Expenses (in $) in Namibia in 2009?
Provide a succinct answer. 5.66e+1. What is the difference between the Expenses (in $) of Mongolia in 2006 and the Expenses (in $) of Tunisia in 2009?
Give a very brief answer. 6.43e+1. What is the difference between the Expenses (in $) in Namibia in 2006 and the Expenses (in $) in Tunisia in 2009?
Give a very brief answer. 5.73e+09. What is the difference between the Expenses (in $) in Mali in 2007 and the Expenses (in $) in Mongolia in 2008?
Your answer should be very brief. -5.54e+1. What is the difference between the Expenses (in $) in Mali in 2007 and the Expenses (in $) in Namibia in 2008?
Offer a terse response. 7.82e+1. What is the difference between the Expenses (in $) in Mali in 2007 and the Expenses (in $) in Tunisia in 2008?
Ensure brevity in your answer.  8.58e+1. What is the difference between the Expenses (in $) of Mongolia in 2007 and the Expenses (in $) of Namibia in 2008?
Keep it short and to the point. 8.78e+1. What is the difference between the Expenses (in $) in Mongolia in 2007 and the Expenses (in $) in Tunisia in 2008?
Give a very brief answer. 9.53e+1. What is the difference between the Expenses (in $) in Namibia in 2007 and the Expenses (in $) in Tunisia in 2008?
Keep it short and to the point. 7.15e+09. What is the difference between the Expenses (in $) of Mali in 2007 and the Expenses (in $) of Mongolia in 2009?
Your answer should be compact. -2.45e+1. What is the difference between the Expenses (in $) in Mali in 2007 and the Expenses (in $) in Namibia in 2009?
Make the answer very short. 7.81e+1. What is the difference between the Expenses (in $) of Mali in 2007 and the Expenses (in $) of Tunisia in 2009?
Offer a terse response. 8.57e+1. What is the difference between the Expenses (in $) of Mongolia in 2007 and the Expenses (in $) of Namibia in 2009?
Your answer should be compact. 8.77e+1. What is the difference between the Expenses (in $) in Mongolia in 2007 and the Expenses (in $) in Tunisia in 2009?
Provide a succinct answer. 9.53e+1. What is the difference between the Expenses (in $) in Namibia in 2007 and the Expenses (in $) in Tunisia in 2009?
Ensure brevity in your answer.  7.11e+09. What is the difference between the Expenses (in $) of Mali in 2008 and the Expenses (in $) of Mongolia in 2009?
Make the answer very short. -4.69e+1. What is the difference between the Expenses (in $) of Mali in 2008 and the Expenses (in $) of Namibia in 2009?
Keep it short and to the point. 5.57e+1. What is the difference between the Expenses (in $) in Mali in 2008 and the Expenses (in $) in Tunisia in 2009?
Offer a terse response. 6.33e+1. What is the difference between the Expenses (in $) of Mongolia in 2008 and the Expenses (in $) of Namibia in 2009?
Your response must be concise. 1.33e+11. What is the difference between the Expenses (in $) in Mongolia in 2008 and the Expenses (in $) in Tunisia in 2009?
Your answer should be compact. 1.41e+11. What is the difference between the Expenses (in $) of Namibia in 2008 and the Expenses (in $) of Tunisia in 2009?
Keep it short and to the point. 7.53e+09. What is the average Expenses (in $) of Mali per year?
Ensure brevity in your answer.  6.05e+1. What is the average Expenses (in $) in Mongolia per year?
Make the answer very short. 6.41e+1. What is the average Expenses (in $) of Namibia per year?
Offer a terse response. 5.38e+09. What is the average Expenses (in $) of Tunisia per year?
Your response must be concise. 8.31e+08. In the year 2000, what is the difference between the Expenses (in $) of Mali and Expenses (in $) of Mongolia?
Keep it short and to the point. 1.93e+1. In the year 2000, what is the difference between the Expenses (in $) of Mali and Expenses (in $) of Namibia?
Ensure brevity in your answer.  3.36e+1. In the year 2000, what is the difference between the Expenses (in $) of Mali and Expenses (in $) of Tunisia?
Your response must be concise. 3.57e+1. In the year 2000, what is the difference between the Expenses (in $) in Mongolia and Expenses (in $) in Namibia?
Your answer should be compact. 1.43e+1. In the year 2000, what is the difference between the Expenses (in $) in Mongolia and Expenses (in $) in Tunisia?
Keep it short and to the point. 1.63e+1. In the year 2000, what is the difference between the Expenses (in $) of Namibia and Expenses (in $) of Tunisia?
Ensure brevity in your answer.  2.06e+09. In the year 2001, what is the difference between the Expenses (in $) in Mali and Expenses (in $) in Mongolia?
Your answer should be very brief. 1.42e+1. In the year 2001, what is the difference between the Expenses (in $) in Mali and Expenses (in $) in Namibia?
Your answer should be compact. 3.76e+1. In the year 2001, what is the difference between the Expenses (in $) in Mali and Expenses (in $) in Tunisia?
Give a very brief answer. 3.93e+1. In the year 2001, what is the difference between the Expenses (in $) in Mongolia and Expenses (in $) in Namibia?
Your response must be concise. 2.33e+1. In the year 2001, what is the difference between the Expenses (in $) of Mongolia and Expenses (in $) of Tunisia?
Make the answer very short. 2.51e+1. In the year 2001, what is the difference between the Expenses (in $) in Namibia and Expenses (in $) in Tunisia?
Provide a short and direct response. 1.78e+09. In the year 2002, what is the difference between the Expenses (in $) in Mali and Expenses (in $) in Mongolia?
Ensure brevity in your answer.  2.48e+1. In the year 2002, what is the difference between the Expenses (in $) of Mali and Expenses (in $) of Namibia?
Give a very brief answer. 4.60e+1. In the year 2002, what is the difference between the Expenses (in $) of Mali and Expenses (in $) of Tunisia?
Your answer should be very brief. 4.78e+1. In the year 2002, what is the difference between the Expenses (in $) of Mongolia and Expenses (in $) of Namibia?
Offer a terse response. 2.12e+1. In the year 2002, what is the difference between the Expenses (in $) of Mongolia and Expenses (in $) of Tunisia?
Make the answer very short. 2.30e+1. In the year 2002, what is the difference between the Expenses (in $) in Namibia and Expenses (in $) in Tunisia?
Offer a terse response. 1.82e+09. In the year 2003, what is the difference between the Expenses (in $) of Mali and Expenses (in $) of Mongolia?
Offer a very short reply. 2.73e+1. In the year 2003, what is the difference between the Expenses (in $) of Mali and Expenses (in $) of Namibia?
Make the answer very short. 5.53e+1. In the year 2003, what is the difference between the Expenses (in $) of Mali and Expenses (in $) of Tunisia?
Your answer should be compact. 5.77e+1. In the year 2003, what is the difference between the Expenses (in $) of Mongolia and Expenses (in $) of Namibia?
Your answer should be very brief. 2.80e+1. In the year 2003, what is the difference between the Expenses (in $) of Mongolia and Expenses (in $) of Tunisia?
Offer a very short reply. 3.03e+1. In the year 2003, what is the difference between the Expenses (in $) in Namibia and Expenses (in $) in Tunisia?
Your answer should be very brief. 2.32e+09. In the year 2006, what is the difference between the Expenses (in $) of Mali and Expenses (in $) of Mongolia?
Provide a succinct answer. -5.76e+09. In the year 2006, what is the difference between the Expenses (in $) in Mali and Expenses (in $) in Namibia?
Offer a very short reply. 5.28e+1. In the year 2006, what is the difference between the Expenses (in $) in Mali and Expenses (in $) in Tunisia?
Your response must be concise. 5.87e+1. In the year 2006, what is the difference between the Expenses (in $) of Mongolia and Expenses (in $) of Namibia?
Offer a very short reply. 5.85e+1. In the year 2006, what is the difference between the Expenses (in $) of Mongolia and Expenses (in $) of Tunisia?
Your answer should be very brief. 6.45e+1. In the year 2006, what is the difference between the Expenses (in $) in Namibia and Expenses (in $) in Tunisia?
Your answer should be very brief. 5.95e+09. In the year 2007, what is the difference between the Expenses (in $) of Mali and Expenses (in $) of Mongolia?
Your answer should be compact. -9.56e+09. In the year 2007, what is the difference between the Expenses (in $) of Mali and Expenses (in $) of Namibia?
Keep it short and to the point. 7.86e+1. In the year 2007, what is the difference between the Expenses (in $) of Mali and Expenses (in $) of Tunisia?
Provide a succinct answer. 8.59e+1. In the year 2007, what is the difference between the Expenses (in $) of Mongolia and Expenses (in $) of Namibia?
Your response must be concise. 8.82e+1. In the year 2007, what is the difference between the Expenses (in $) in Mongolia and Expenses (in $) in Tunisia?
Offer a terse response. 9.55e+1. In the year 2007, what is the difference between the Expenses (in $) in Namibia and Expenses (in $) in Tunisia?
Offer a terse response. 7.28e+09. In the year 2008, what is the difference between the Expenses (in $) in Mali and Expenses (in $) in Mongolia?
Provide a succinct answer. -7.78e+1. In the year 2008, what is the difference between the Expenses (in $) in Mali and Expenses (in $) in Namibia?
Offer a terse response. 5.58e+1. In the year 2008, what is the difference between the Expenses (in $) in Mali and Expenses (in $) in Tunisia?
Offer a terse response. 6.34e+1. In the year 2008, what is the difference between the Expenses (in $) in Mongolia and Expenses (in $) in Namibia?
Give a very brief answer. 1.34e+11. In the year 2008, what is the difference between the Expenses (in $) of Mongolia and Expenses (in $) of Tunisia?
Provide a succinct answer. 1.41e+11. In the year 2008, what is the difference between the Expenses (in $) of Namibia and Expenses (in $) of Tunisia?
Keep it short and to the point. 7.56e+09. In the year 2009, what is the difference between the Expenses (in $) in Mali and Expenses (in $) in Mongolia?
Provide a short and direct response. -2.12e+1. In the year 2009, what is the difference between the Expenses (in $) in Mali and Expenses (in $) in Namibia?
Provide a short and direct response. 8.15e+1. In the year 2009, what is the difference between the Expenses (in $) in Mali and Expenses (in $) in Tunisia?
Offer a very short reply. 8.91e+1. In the year 2009, what is the difference between the Expenses (in $) of Mongolia and Expenses (in $) of Namibia?
Provide a succinct answer. 1.03e+11. In the year 2009, what is the difference between the Expenses (in $) of Mongolia and Expenses (in $) of Tunisia?
Offer a very short reply. 1.10e+11. In the year 2009, what is the difference between the Expenses (in $) in Namibia and Expenses (in $) in Tunisia?
Keep it short and to the point. 7.61e+09. What is the ratio of the Expenses (in $) of Mali in 2000 to that in 2001?
Provide a succinct answer. 0.91. What is the ratio of the Expenses (in $) of Mongolia in 2000 to that in 2001?
Provide a short and direct response. 0.66. What is the ratio of the Expenses (in $) in Namibia in 2000 to that in 2001?
Provide a short and direct response. 1.09. What is the ratio of the Expenses (in $) in Tunisia in 2000 to that in 2001?
Make the answer very short. 0.95. What is the ratio of the Expenses (in $) of Mali in 2000 to that in 2002?
Provide a succinct answer. 0.75. What is the ratio of the Expenses (in $) in Mongolia in 2000 to that in 2002?
Offer a very short reply. 0.72. What is the ratio of the Expenses (in $) in Namibia in 2000 to that in 2002?
Your response must be concise. 1.11. What is the ratio of the Expenses (in $) of Tunisia in 2000 to that in 2002?
Keep it short and to the point. 1.05. What is the ratio of the Expenses (in $) in Mali in 2000 to that in 2003?
Your answer should be compact. 0.62. What is the ratio of the Expenses (in $) of Mongolia in 2000 to that in 2003?
Your answer should be compact. 0.55. What is the ratio of the Expenses (in $) in Namibia in 2000 to that in 2003?
Offer a very short reply. 0.95. What is the ratio of the Expenses (in $) in Tunisia in 2000 to that in 2003?
Offer a very short reply. 1.15. What is the ratio of the Expenses (in $) in Mali in 2000 to that in 2006?
Ensure brevity in your answer.  0.61. What is the ratio of the Expenses (in $) in Mongolia in 2000 to that in 2006?
Offer a terse response. 0.26. What is the ratio of the Expenses (in $) of Namibia in 2000 to that in 2006?
Give a very brief answer. 0.43. What is the ratio of the Expenses (in $) in Tunisia in 2000 to that in 2006?
Your answer should be compact. 1.1. What is the ratio of the Expenses (in $) in Mali in 2000 to that in 2007?
Offer a very short reply. 0.42. What is the ratio of the Expenses (in $) of Mongolia in 2000 to that in 2007?
Provide a succinct answer. 0.18. What is the ratio of the Expenses (in $) of Namibia in 2000 to that in 2007?
Your answer should be very brief. 0.36. What is the ratio of the Expenses (in $) in Tunisia in 2000 to that in 2007?
Keep it short and to the point. 1.02. What is the ratio of the Expenses (in $) of Mali in 2000 to that in 2008?
Offer a very short reply. 0.57. What is the ratio of the Expenses (in $) in Mongolia in 2000 to that in 2008?
Provide a succinct answer. 0.12. What is the ratio of the Expenses (in $) in Namibia in 2000 to that in 2008?
Offer a very short reply. 0.34. What is the ratio of the Expenses (in $) in Mali in 2000 to that in 2009?
Ensure brevity in your answer.  0.41. What is the ratio of the Expenses (in $) of Mongolia in 2000 to that in 2009?
Give a very brief answer. 0.15. What is the ratio of the Expenses (in $) of Namibia in 2000 to that in 2009?
Your answer should be very brief. 0.34. What is the ratio of the Expenses (in $) in Tunisia in 2000 to that in 2009?
Give a very brief answer. 0.85. What is the ratio of the Expenses (in $) in Mali in 2001 to that in 2002?
Give a very brief answer. 0.83. What is the ratio of the Expenses (in $) in Mongolia in 2001 to that in 2002?
Ensure brevity in your answer.  1.09. What is the ratio of the Expenses (in $) of Tunisia in 2001 to that in 2002?
Keep it short and to the point. 1.11. What is the ratio of the Expenses (in $) of Mali in 2001 to that in 2003?
Your answer should be compact. 0.69. What is the ratio of the Expenses (in $) in Mongolia in 2001 to that in 2003?
Provide a short and direct response. 0.84. What is the ratio of the Expenses (in $) in Namibia in 2001 to that in 2003?
Your answer should be compact. 0.87. What is the ratio of the Expenses (in $) in Tunisia in 2001 to that in 2003?
Keep it short and to the point. 1.21. What is the ratio of the Expenses (in $) of Mali in 2001 to that in 2006?
Make the answer very short. 0.68. What is the ratio of the Expenses (in $) in Mongolia in 2001 to that in 2006?
Make the answer very short. 0.4. What is the ratio of the Expenses (in $) in Namibia in 2001 to that in 2006?
Your answer should be very brief. 0.39. What is the ratio of the Expenses (in $) of Tunisia in 2001 to that in 2006?
Your answer should be compact. 1.16. What is the ratio of the Expenses (in $) of Mali in 2001 to that in 2007?
Offer a very short reply. 0.46. What is the ratio of the Expenses (in $) in Mongolia in 2001 to that in 2007?
Offer a terse response. 0.27. What is the ratio of the Expenses (in $) in Namibia in 2001 to that in 2007?
Make the answer very short. 0.33. What is the ratio of the Expenses (in $) in Tunisia in 2001 to that in 2007?
Your response must be concise. 1.08. What is the ratio of the Expenses (in $) of Mali in 2001 to that in 2008?
Ensure brevity in your answer.  0.63. What is the ratio of the Expenses (in $) in Mongolia in 2001 to that in 2008?
Give a very brief answer. 0.18. What is the ratio of the Expenses (in $) of Namibia in 2001 to that in 2008?
Provide a short and direct response. 0.31. What is the ratio of the Expenses (in $) in Tunisia in 2001 to that in 2008?
Offer a very short reply. 0.92. What is the ratio of the Expenses (in $) in Mali in 2001 to that in 2009?
Your answer should be compact. 0.45. What is the ratio of the Expenses (in $) of Mongolia in 2001 to that in 2009?
Your answer should be compact. 0.23. What is the ratio of the Expenses (in $) of Namibia in 2001 to that in 2009?
Your answer should be compact. 0.31. What is the ratio of the Expenses (in $) in Tunisia in 2001 to that in 2009?
Offer a very short reply. 0.89. What is the ratio of the Expenses (in $) of Mali in 2002 to that in 2003?
Your response must be concise. 0.83. What is the ratio of the Expenses (in $) in Mongolia in 2002 to that in 2003?
Offer a terse response. 0.77. What is the ratio of the Expenses (in $) in Namibia in 2002 to that in 2003?
Offer a very short reply. 0.86. What is the ratio of the Expenses (in $) in Tunisia in 2002 to that in 2003?
Ensure brevity in your answer.  1.09. What is the ratio of the Expenses (in $) in Mali in 2002 to that in 2006?
Offer a terse response. 0.82. What is the ratio of the Expenses (in $) in Mongolia in 2002 to that in 2006?
Offer a terse response. 0.36. What is the ratio of the Expenses (in $) in Namibia in 2002 to that in 2006?
Provide a succinct answer. 0.39. What is the ratio of the Expenses (in $) of Tunisia in 2002 to that in 2006?
Provide a short and direct response. 1.05. What is the ratio of the Expenses (in $) of Mali in 2002 to that in 2007?
Keep it short and to the point. 0.56. What is the ratio of the Expenses (in $) in Mongolia in 2002 to that in 2007?
Offer a very short reply. 0.25. What is the ratio of the Expenses (in $) in Namibia in 2002 to that in 2007?
Your response must be concise. 0.32. What is the ratio of the Expenses (in $) in Tunisia in 2002 to that in 2007?
Offer a terse response. 0.97. What is the ratio of the Expenses (in $) of Mali in 2002 to that in 2008?
Provide a succinct answer. 0.76. What is the ratio of the Expenses (in $) in Mongolia in 2002 to that in 2008?
Give a very brief answer. 0.17. What is the ratio of the Expenses (in $) of Namibia in 2002 to that in 2008?
Your response must be concise. 0.31. What is the ratio of the Expenses (in $) of Tunisia in 2002 to that in 2008?
Your answer should be very brief. 0.83. What is the ratio of the Expenses (in $) of Mali in 2002 to that in 2009?
Offer a terse response. 0.54. What is the ratio of the Expenses (in $) in Mongolia in 2002 to that in 2009?
Offer a very short reply. 0.21. What is the ratio of the Expenses (in $) of Namibia in 2002 to that in 2009?
Offer a terse response. 0.3. What is the ratio of the Expenses (in $) of Tunisia in 2002 to that in 2009?
Offer a terse response. 0.8. What is the ratio of the Expenses (in $) in Mali in 2003 to that in 2006?
Your response must be concise. 0.98. What is the ratio of the Expenses (in $) of Mongolia in 2003 to that in 2006?
Keep it short and to the point. 0.48. What is the ratio of the Expenses (in $) of Namibia in 2003 to that in 2006?
Ensure brevity in your answer.  0.45. What is the ratio of the Expenses (in $) in Tunisia in 2003 to that in 2006?
Provide a succinct answer. 0.96. What is the ratio of the Expenses (in $) in Mali in 2003 to that in 2007?
Your response must be concise. 0.67. What is the ratio of the Expenses (in $) in Mongolia in 2003 to that in 2007?
Offer a very short reply. 0.32. What is the ratio of the Expenses (in $) in Namibia in 2003 to that in 2007?
Provide a short and direct response. 0.38. What is the ratio of the Expenses (in $) in Tunisia in 2003 to that in 2007?
Your answer should be compact. 0.89. What is the ratio of the Expenses (in $) in Mali in 2003 to that in 2008?
Your response must be concise. 0.91. What is the ratio of the Expenses (in $) of Mongolia in 2003 to that in 2008?
Your answer should be compact. 0.22. What is the ratio of the Expenses (in $) of Namibia in 2003 to that in 2008?
Provide a short and direct response. 0.36. What is the ratio of the Expenses (in $) of Tunisia in 2003 to that in 2008?
Keep it short and to the point. 0.76. What is the ratio of the Expenses (in $) of Mali in 2003 to that in 2009?
Your response must be concise. 0.65. What is the ratio of the Expenses (in $) of Mongolia in 2003 to that in 2009?
Make the answer very short. 0.28. What is the ratio of the Expenses (in $) of Namibia in 2003 to that in 2009?
Your answer should be very brief. 0.35. What is the ratio of the Expenses (in $) in Tunisia in 2003 to that in 2009?
Ensure brevity in your answer.  0.74. What is the ratio of the Expenses (in $) of Mali in 2006 to that in 2007?
Your answer should be compact. 0.69. What is the ratio of the Expenses (in $) of Mongolia in 2006 to that in 2007?
Your response must be concise. 0.68. What is the ratio of the Expenses (in $) of Namibia in 2006 to that in 2007?
Make the answer very short. 0.83. What is the ratio of the Expenses (in $) of Tunisia in 2006 to that in 2007?
Keep it short and to the point. 0.93. What is the ratio of the Expenses (in $) of Mali in 2006 to that in 2008?
Offer a very short reply. 0.92. What is the ratio of the Expenses (in $) of Mongolia in 2006 to that in 2008?
Your answer should be very brief. 0.46. What is the ratio of the Expenses (in $) in Namibia in 2006 to that in 2008?
Ensure brevity in your answer.  0.79. What is the ratio of the Expenses (in $) of Tunisia in 2006 to that in 2008?
Offer a very short reply. 0.79. What is the ratio of the Expenses (in $) in Mali in 2006 to that in 2009?
Your answer should be very brief. 0.66. What is the ratio of the Expenses (in $) in Mongolia in 2006 to that in 2009?
Give a very brief answer. 0.59. What is the ratio of the Expenses (in $) in Namibia in 2006 to that in 2009?
Give a very brief answer. 0.78. What is the ratio of the Expenses (in $) of Tunisia in 2006 to that in 2009?
Offer a terse response. 0.77. What is the ratio of the Expenses (in $) of Mali in 2007 to that in 2008?
Give a very brief answer. 1.35. What is the ratio of the Expenses (in $) in Mongolia in 2007 to that in 2008?
Ensure brevity in your answer.  0.68. What is the ratio of the Expenses (in $) in Namibia in 2007 to that in 2008?
Your answer should be compact. 0.95. What is the ratio of the Expenses (in $) in Tunisia in 2007 to that in 2008?
Your response must be concise. 0.85. What is the ratio of the Expenses (in $) of Mali in 2007 to that in 2009?
Your answer should be very brief. 0.96. What is the ratio of the Expenses (in $) in Mongolia in 2007 to that in 2009?
Give a very brief answer. 0.87. What is the ratio of the Expenses (in $) in Namibia in 2007 to that in 2009?
Make the answer very short. 0.94. What is the ratio of the Expenses (in $) of Tunisia in 2007 to that in 2009?
Provide a short and direct response. 0.83. What is the ratio of the Expenses (in $) in Mali in 2008 to that in 2009?
Keep it short and to the point. 0.71. What is the ratio of the Expenses (in $) in Mongolia in 2008 to that in 2009?
Offer a terse response. 1.28. What is the ratio of the Expenses (in $) of Namibia in 2008 to that in 2009?
Make the answer very short. 0.99. What is the ratio of the Expenses (in $) in Tunisia in 2008 to that in 2009?
Offer a terse response. 0.97. What is the difference between the highest and the second highest Expenses (in $) in Mali?
Make the answer very short. 3.36e+09. What is the difference between the highest and the second highest Expenses (in $) in Mongolia?
Make the answer very short. 3.08e+1. What is the difference between the highest and the second highest Expenses (in $) in Namibia?
Offer a terse response. 8.30e+07. What is the difference between the highest and the second highest Expenses (in $) in Tunisia?
Your answer should be compact. 3.20e+07. What is the difference between the highest and the lowest Expenses (in $) of Mali?
Provide a short and direct response. 5.36e+1. What is the difference between the highest and the lowest Expenses (in $) of Mongolia?
Your answer should be compact. 1.25e+11. What is the difference between the highest and the lowest Expenses (in $) of Namibia?
Provide a short and direct response. 5.99e+09. What is the difference between the highest and the lowest Expenses (in $) in Tunisia?
Ensure brevity in your answer.  2.55e+08. 